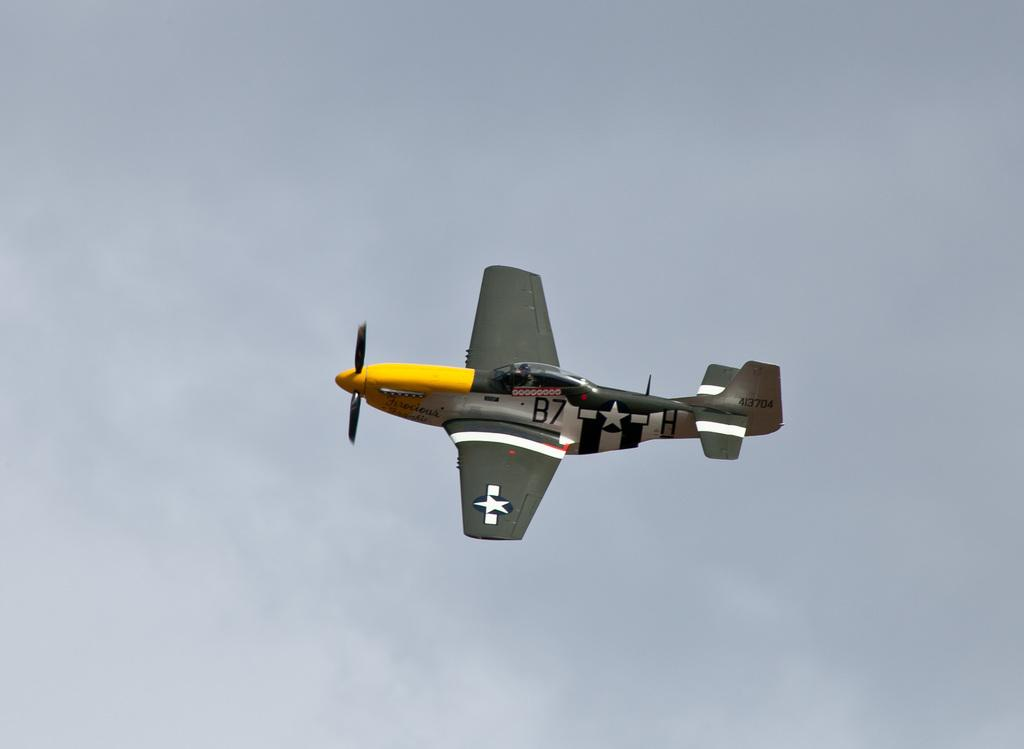<image>
Present a compact description of the photo's key features. An American B-7 single propeller airplane in the sky. 